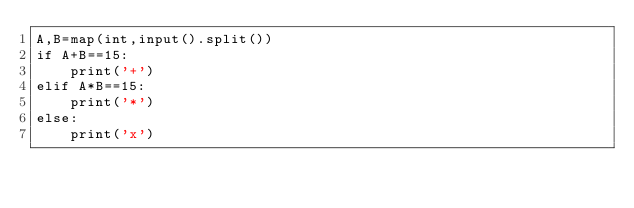<code> <loc_0><loc_0><loc_500><loc_500><_Python_>A,B=map(int,input().split())
if A+B==15:
    print('+')
elif A*B==15:
    print('*')
else:
    print('x')</code> 